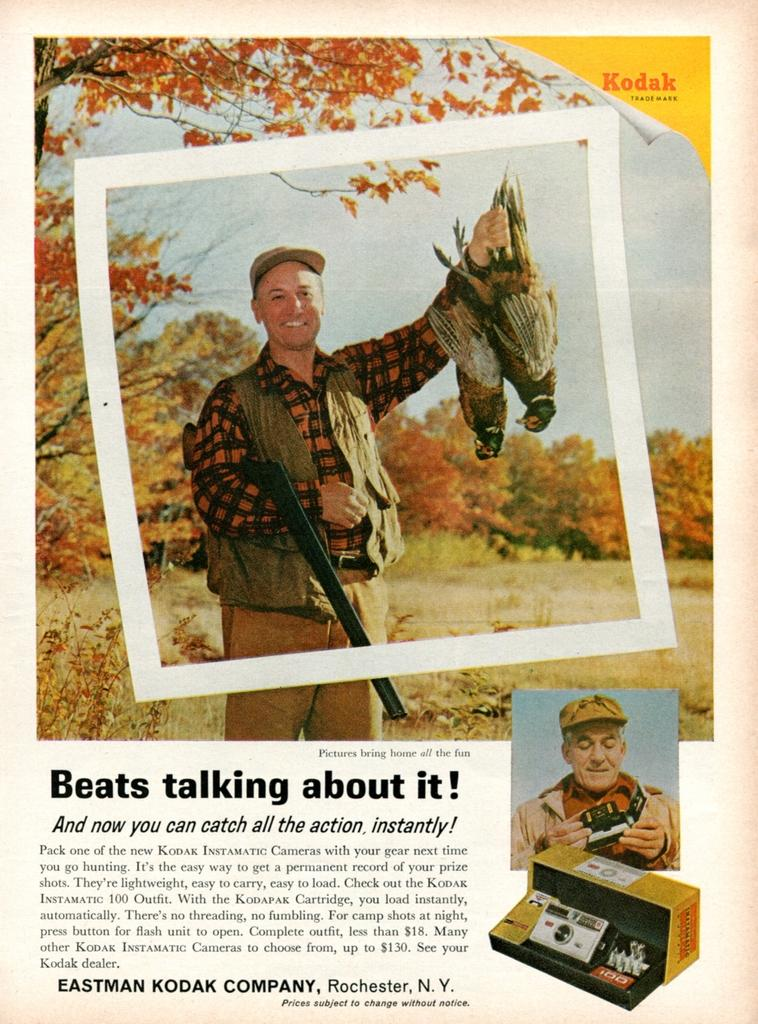What type of visual material is the image? The image is a poster. How many images are included in the poster? The poster contains three images. What else can be found on the poster besides the images? There are texts on the poster. What types of living organisms are depicted in the images? In the images, there are persons, birds, trees, and plants. What background element is present in the images? In the images, there is a sky. What non-living object is present in the images? In the images, there is an object. What type of horn can be heard in the image? There is no horn present in the image, and therefore no sound can be heard. Is there a plane visible in the image? The provided facts do not mention a plane, so it cannot be confirmed from the image. 